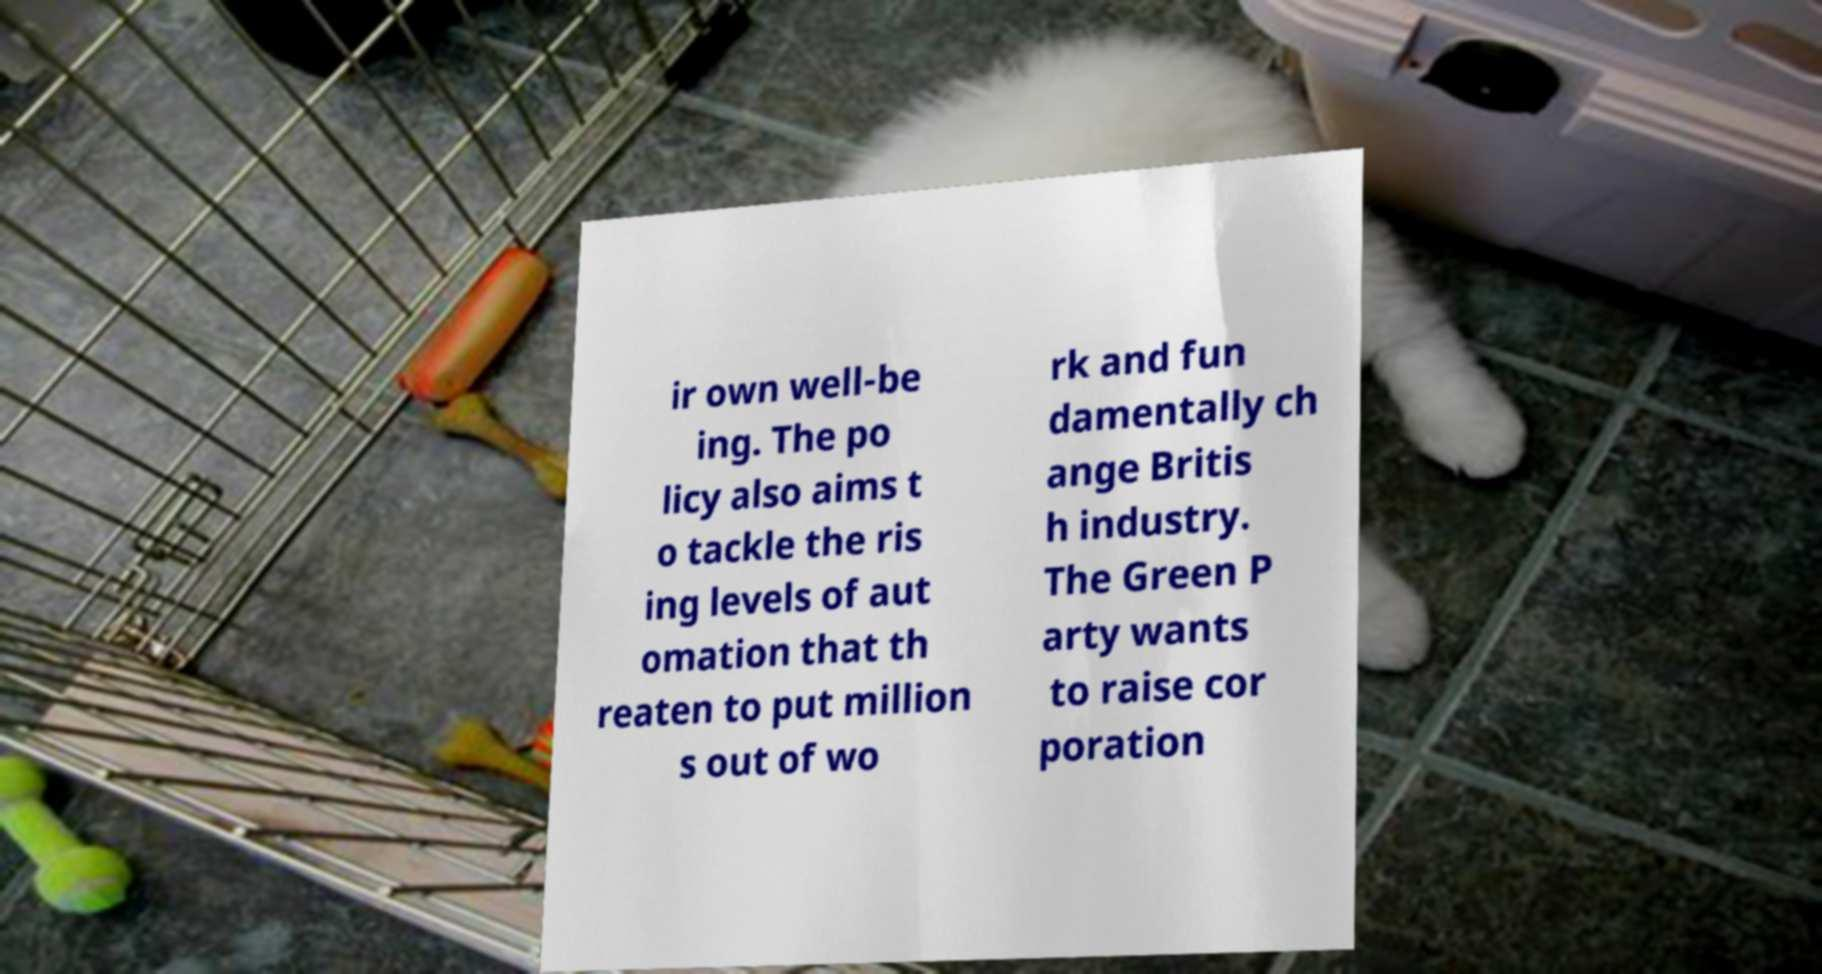What messages or text are displayed in this image? I need them in a readable, typed format. ir own well-be ing. The po licy also aims t o tackle the ris ing levels of aut omation that th reaten to put million s out of wo rk and fun damentally ch ange Britis h industry. The Green P arty wants to raise cor poration 